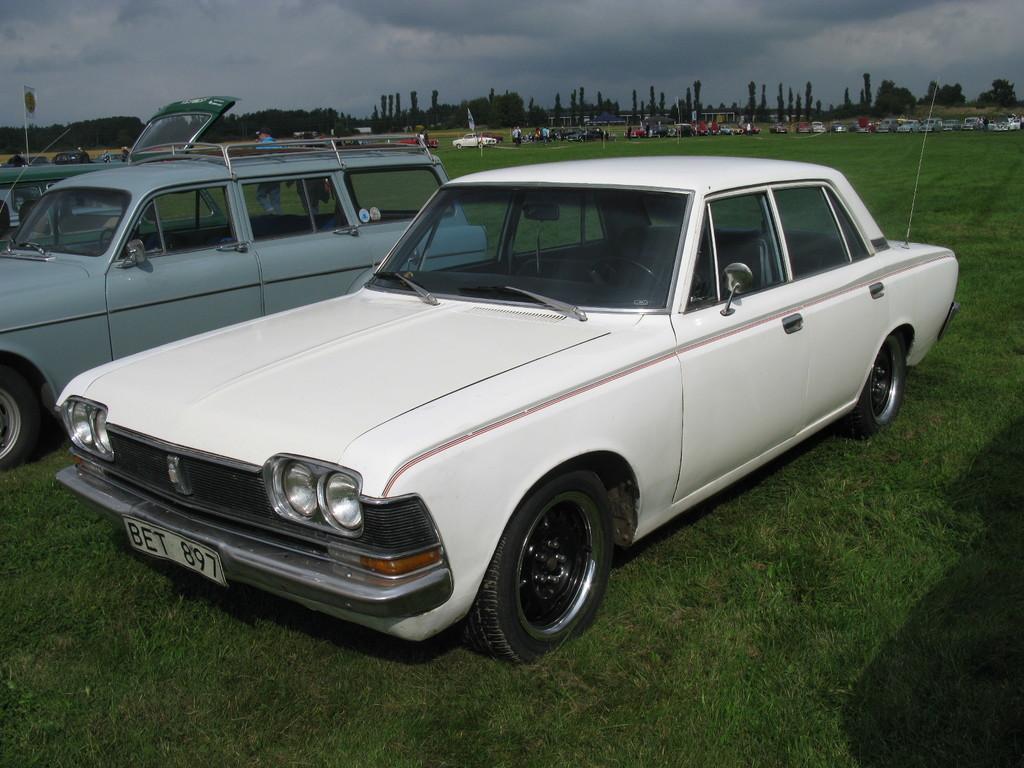In one or two sentences, can you explain what this image depicts? Here we can see three vehicles on the grass. In the background there are few vehicles,people,poles,trees and clouds in the sky. 